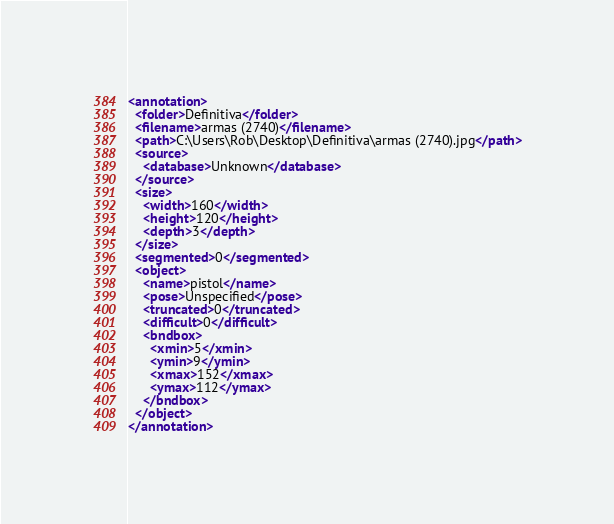Convert code to text. <code><loc_0><loc_0><loc_500><loc_500><_XML_><annotation>
  <folder>Definitiva</folder>
  <filename>armas (2740)</filename>
  <path>C:\Users\Rob\Desktop\Definitiva\armas (2740).jpg</path>
  <source>
    <database>Unknown</database>
  </source>
  <size>
    <width>160</width>
    <height>120</height>
    <depth>3</depth>
  </size>
  <segmented>0</segmented>
  <object>
    <name>pistol</name>
    <pose>Unspecified</pose>
    <truncated>0</truncated>
    <difficult>0</difficult>
    <bndbox>
      <xmin>5</xmin>
      <ymin>9</ymin>
      <xmax>152</xmax>
      <ymax>112</ymax>
    </bndbox>
  </object>
</annotation>
</code> 